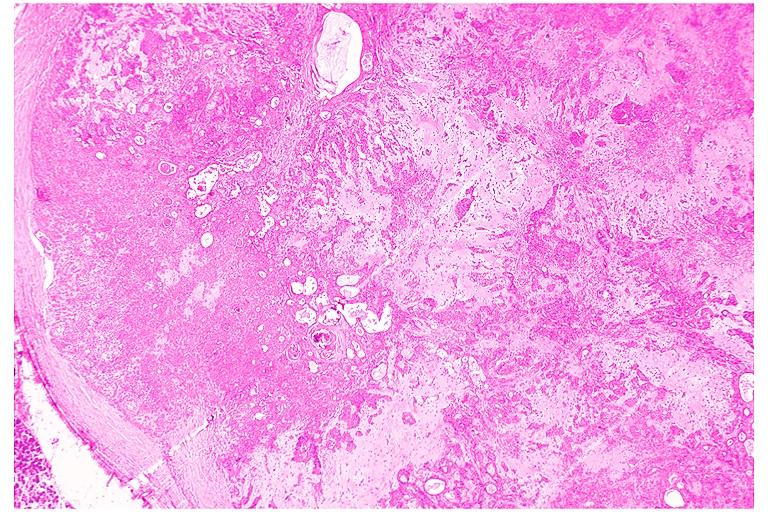s oral present?
Answer the question using a single word or phrase. Yes 